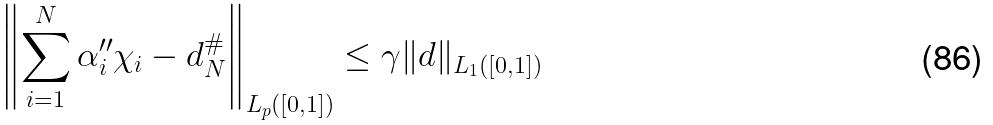Convert formula to latex. <formula><loc_0><loc_0><loc_500><loc_500>\left \| \sum _ { i = 1 } ^ { N } \alpha ^ { \prime \prime } _ { i } \chi _ { i } - d ^ { \# } _ { N } \right \| _ { L _ { p } ( [ 0 , 1 ] ) } \leq \gamma \| d \| _ { L _ { 1 } ( [ 0 , 1 ] ) }</formula> 